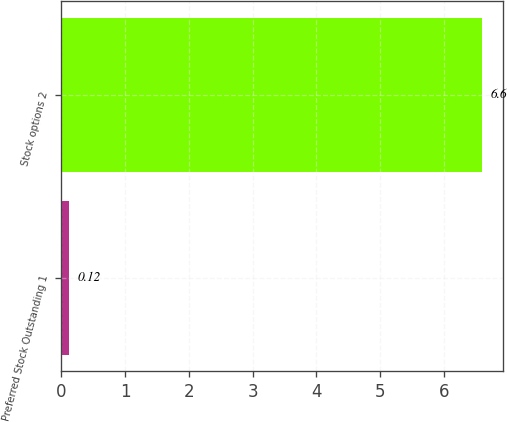Convert chart. <chart><loc_0><loc_0><loc_500><loc_500><bar_chart><fcel>Preferred Stock Outstanding 1<fcel>Stock options 2<nl><fcel>0.12<fcel>6.6<nl></chart> 